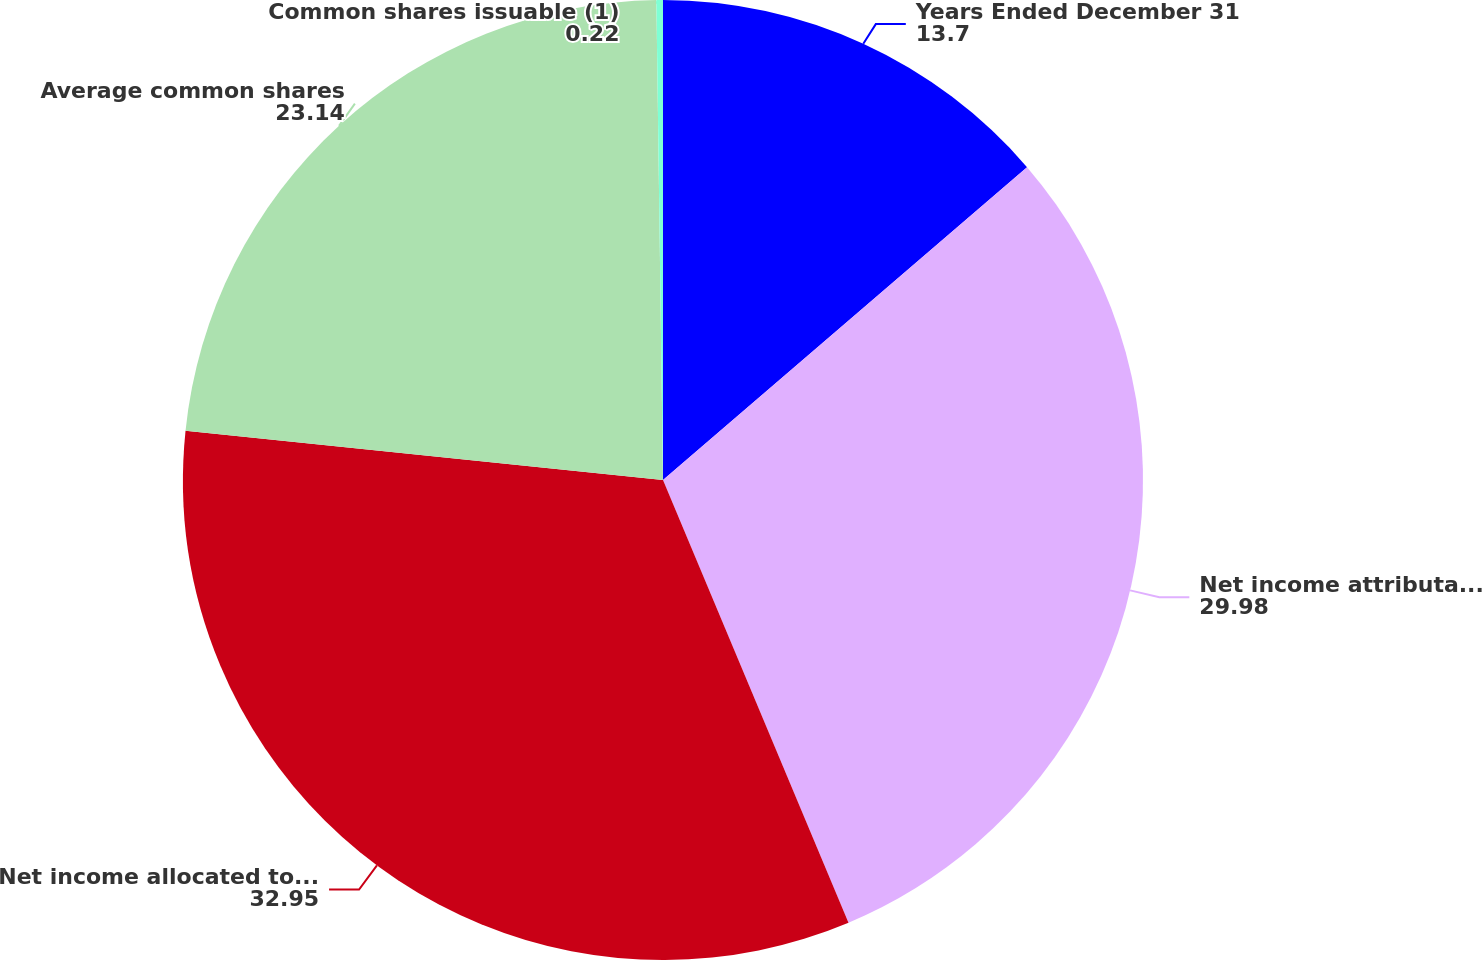Convert chart to OTSL. <chart><loc_0><loc_0><loc_500><loc_500><pie_chart><fcel>Years Ended December 31<fcel>Net income attributable to<fcel>Net income allocated to common<fcel>Average common shares<fcel>Common shares issuable (1)<nl><fcel>13.7%<fcel>29.98%<fcel>32.95%<fcel>23.14%<fcel>0.22%<nl></chart> 